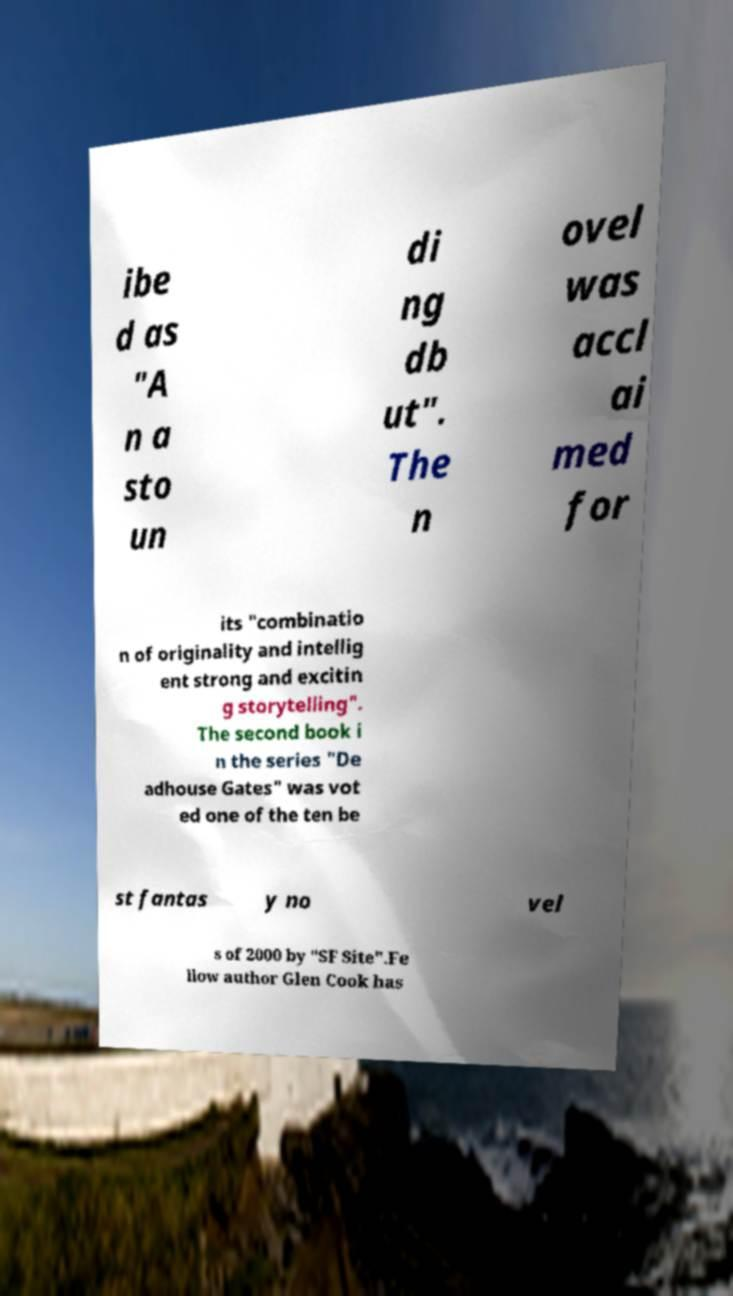Please identify and transcribe the text found in this image. ibe d as "A n a sto un di ng db ut". The n ovel was accl ai med for its "combinatio n of originality and intellig ent strong and excitin g storytelling". The second book i n the series "De adhouse Gates" was vot ed one of the ten be st fantas y no vel s of 2000 by "SF Site".Fe llow author Glen Cook has 